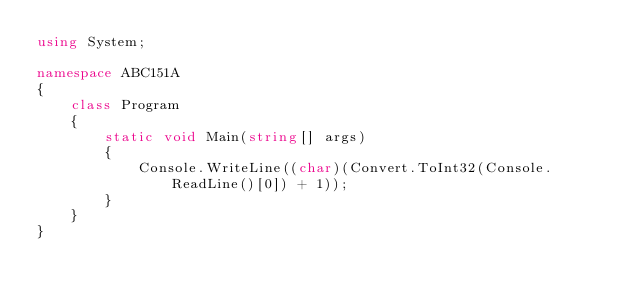Convert code to text. <code><loc_0><loc_0><loc_500><loc_500><_C#_>using System;

namespace ABC151A
{
    class Program
    {
        static void Main(string[] args)
        {
            Console.WriteLine((char)(Convert.ToInt32(Console.ReadLine()[0]) + 1));
        }
    }
}</code> 